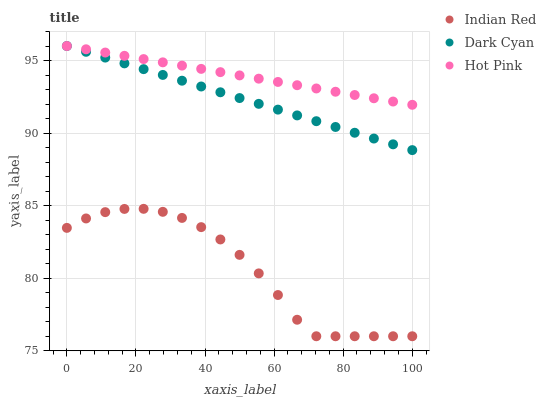Does Indian Red have the minimum area under the curve?
Answer yes or no. Yes. Does Hot Pink have the maximum area under the curve?
Answer yes or no. Yes. Does Hot Pink have the minimum area under the curve?
Answer yes or no. No. Does Indian Red have the maximum area under the curve?
Answer yes or no. No. Is Dark Cyan the smoothest?
Answer yes or no. Yes. Is Indian Red the roughest?
Answer yes or no. Yes. Is Hot Pink the smoothest?
Answer yes or no. No. Is Hot Pink the roughest?
Answer yes or no. No. Does Indian Red have the lowest value?
Answer yes or no. Yes. Does Hot Pink have the lowest value?
Answer yes or no. No. Does Hot Pink have the highest value?
Answer yes or no. Yes. Does Indian Red have the highest value?
Answer yes or no. No. Is Indian Red less than Dark Cyan?
Answer yes or no. Yes. Is Hot Pink greater than Indian Red?
Answer yes or no. Yes. Does Dark Cyan intersect Hot Pink?
Answer yes or no. Yes. Is Dark Cyan less than Hot Pink?
Answer yes or no. No. Is Dark Cyan greater than Hot Pink?
Answer yes or no. No. Does Indian Red intersect Dark Cyan?
Answer yes or no. No. 